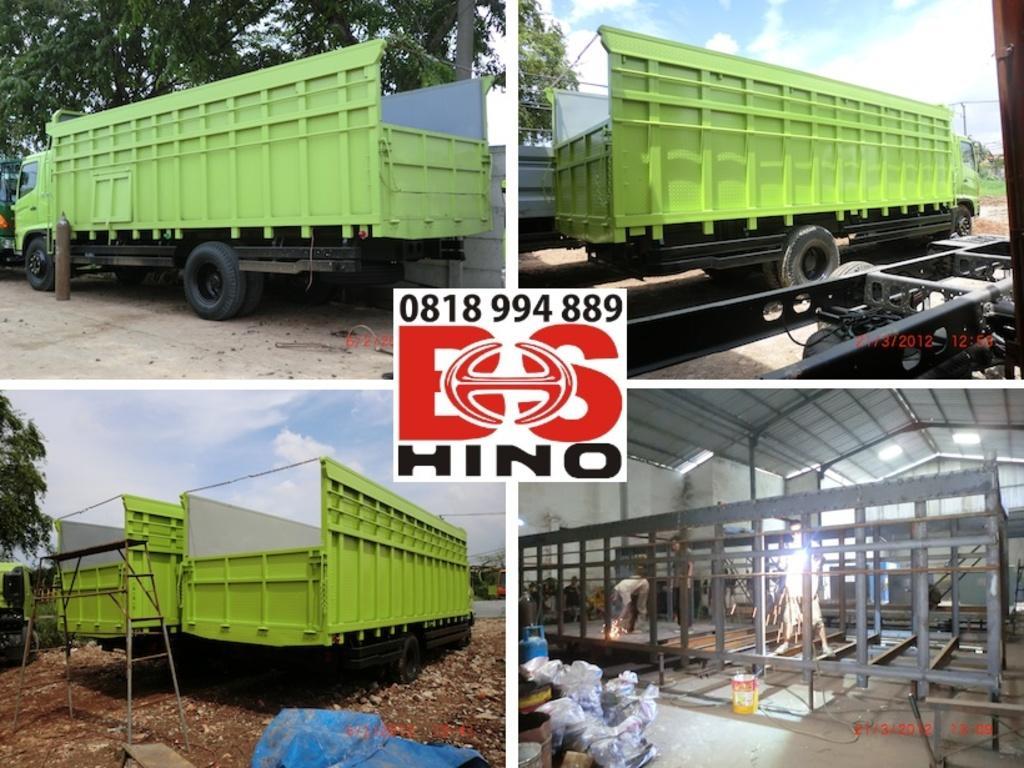Describe this image in one or two sentences. This is a collage image. In this collage image we can see motor vehicles, trees, polythene covers, persons standing on the floor, iron grills, electric lights, containers and sky with clouds. In the center of the collage image we can see a logo. 